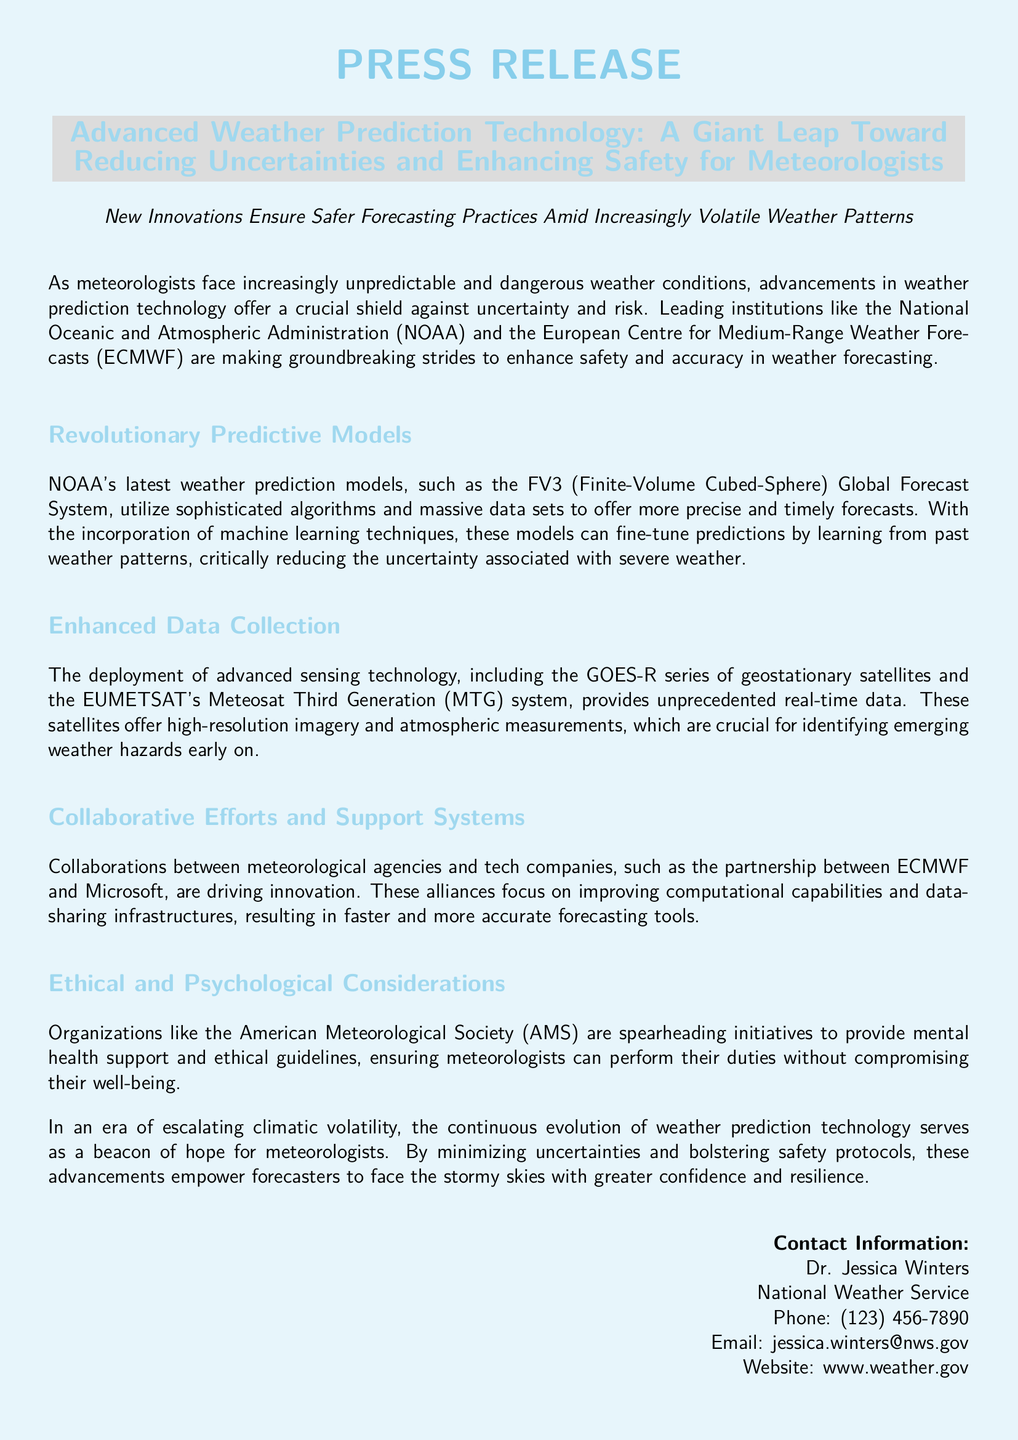What is the title of the press release? The title of the press release is highlighted in bold at the top of the document.
Answer: Advanced Weather Prediction Technology: A Giant Leap Toward Reducing Uncertainties and Enhancing Safety for Meteorologists Who is the contact person mentioned in the document? The contact person is listed at the end of the document with their contact details.
Answer: Dr. Jessica Winters What advancement is highlighted for weather prediction? The document discusses recent advancements made by organizations, specifically mentioning models used in weather prediction.
Answer: FV3 Global Forecast System Which two organizations are mentioned as leading institutions in weather prediction? The document explicitly names organizations that are making strides in weather forecasting.
Answer: NOAA and ECMWF What technology does the GOES-R series refer to? The document refers to this series in the context of advanced sensing technology for weather predictions.
Answer: Geostationary satellites What partnership is driving innovation in forecasting tools? The document describes a collaborative effort between two organizations that focuses on improving forecasting capabilities.
Answer: ECMWF and Microsoft What type of support is being provided to meteorologists according to the document? The press release mentions specific initiatives that organizations are undertaking to aid meteorologists in their work.
Answer: Mental health support Why are advanced weather prediction technologies beneficial to meteorologists? The press release outlines the reasons why new technologies are crucial for meteorologists facing unpredictable weather.
Answer: Minimize uncertainties and bolster safety What is the color scheme used in the document? The document's visual design features specific colors that are applied throughout its layout.
Answer: Sky blue and cloud gray 